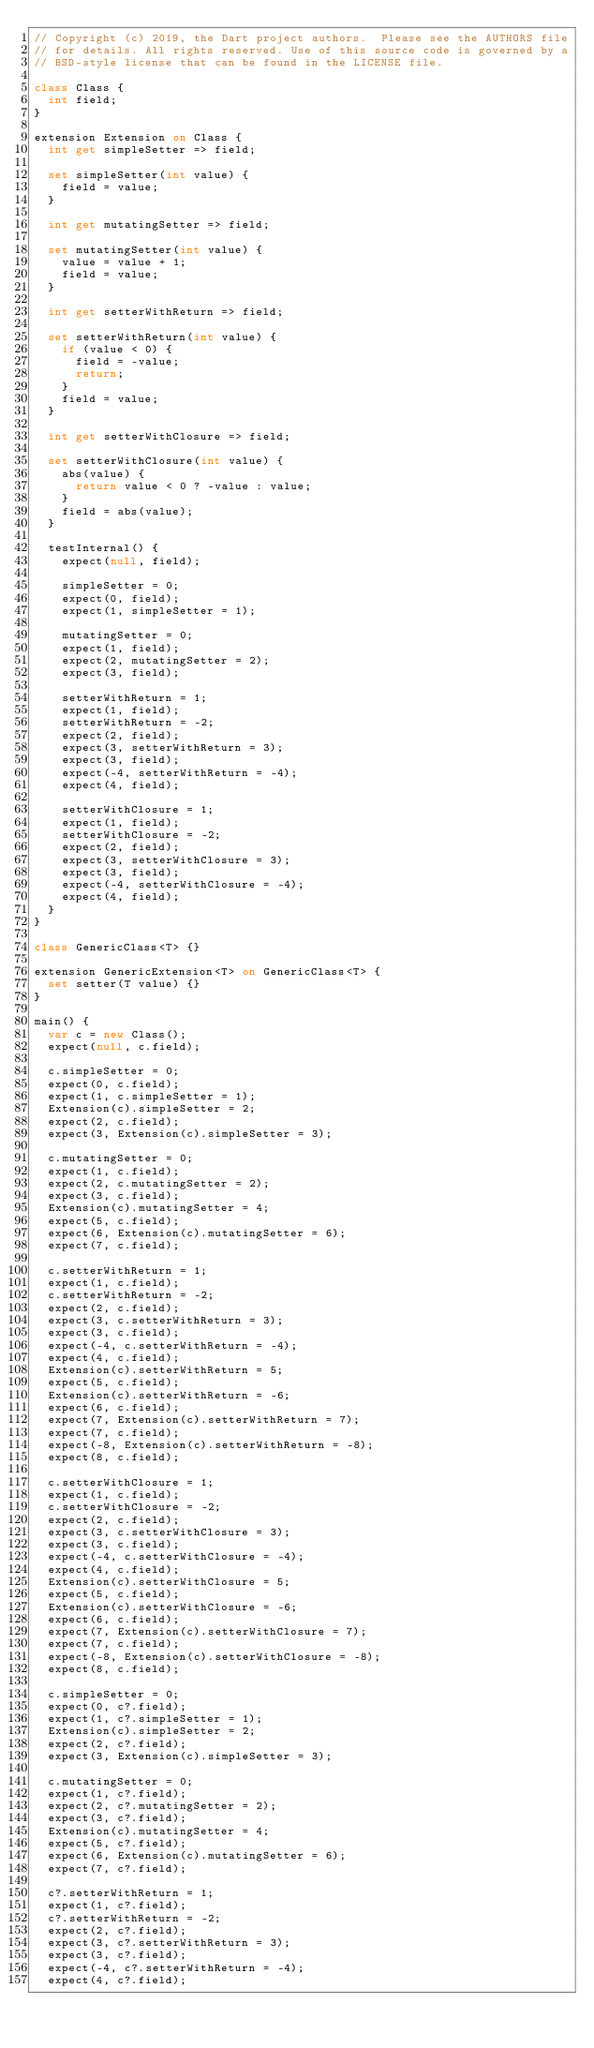<code> <loc_0><loc_0><loc_500><loc_500><_Dart_>// Copyright (c) 2019, the Dart project authors.  Please see the AUTHORS file
// for details. All rights reserved. Use of this source code is governed by a
// BSD-style license that can be found in the LICENSE file.

class Class {
  int field;
}

extension Extension on Class {
  int get simpleSetter => field;

  set simpleSetter(int value) {
    field = value;
  }

  int get mutatingSetter => field;

  set mutatingSetter(int value) {
    value = value + 1;
    field = value;
  }

  int get setterWithReturn => field;

  set setterWithReturn(int value) {
    if (value < 0) {
      field = -value;
      return;
    }
    field = value;
  }

  int get setterWithClosure => field;

  set setterWithClosure(int value) {
    abs(value) {
      return value < 0 ? -value : value;
    }
    field = abs(value);
  }
  
  testInternal() {
    expect(null, field);

    simpleSetter = 0;
    expect(0, field);
    expect(1, simpleSetter = 1);

    mutatingSetter = 0;
    expect(1, field);
    expect(2, mutatingSetter = 2);
    expect(3, field);

    setterWithReturn = 1;
    expect(1, field);
    setterWithReturn = -2;
    expect(2, field);
    expect(3, setterWithReturn = 3);
    expect(3, field);
    expect(-4, setterWithReturn = -4);
    expect(4, field);

    setterWithClosure = 1;
    expect(1, field);
    setterWithClosure = -2;
    expect(2, field);
    expect(3, setterWithClosure = 3);
    expect(3, field);
    expect(-4, setterWithClosure = -4);
    expect(4, field);
  }
}

class GenericClass<T> {}

extension GenericExtension<T> on GenericClass<T> {
  set setter(T value) {}
}

main() {
  var c = new Class();
  expect(null, c.field);

  c.simpleSetter = 0;
  expect(0, c.field);
  expect(1, c.simpleSetter = 1);
  Extension(c).simpleSetter = 2;
  expect(2, c.field);
  expect(3, Extension(c).simpleSetter = 3);

  c.mutatingSetter = 0;
  expect(1, c.field);
  expect(2, c.mutatingSetter = 2);
  expect(3, c.field);
  Extension(c).mutatingSetter = 4;
  expect(5, c.field);
  expect(6, Extension(c).mutatingSetter = 6);
  expect(7, c.field);

  c.setterWithReturn = 1;
  expect(1, c.field);
  c.setterWithReturn = -2;
  expect(2, c.field);
  expect(3, c.setterWithReturn = 3);
  expect(3, c.field);
  expect(-4, c.setterWithReturn = -4);
  expect(4, c.field);
  Extension(c).setterWithReturn = 5;
  expect(5, c.field);
  Extension(c).setterWithReturn = -6;
  expect(6, c.field);
  expect(7, Extension(c).setterWithReturn = 7);
  expect(7, c.field);
  expect(-8, Extension(c).setterWithReturn = -8);
  expect(8, c.field);

  c.setterWithClosure = 1;
  expect(1, c.field);
  c.setterWithClosure = -2;
  expect(2, c.field);
  expect(3, c.setterWithClosure = 3);
  expect(3, c.field);
  expect(-4, c.setterWithClosure = -4);
  expect(4, c.field);
  Extension(c).setterWithClosure = 5;
  expect(5, c.field);
  Extension(c).setterWithClosure = -6;
  expect(6, c.field);
  expect(7, Extension(c).setterWithClosure = 7);
  expect(7, c.field);
  expect(-8, Extension(c).setterWithClosure = -8);
  expect(8, c.field);

  c.simpleSetter = 0;
  expect(0, c?.field);
  expect(1, c?.simpleSetter = 1);
  Extension(c).simpleSetter = 2;
  expect(2, c?.field);
  expect(3, Extension(c).simpleSetter = 3);

  c.mutatingSetter = 0;
  expect(1, c?.field);
  expect(2, c?.mutatingSetter = 2);
  expect(3, c?.field);
  Extension(c).mutatingSetter = 4;
  expect(5, c?.field);
  expect(6, Extension(c).mutatingSetter = 6);
  expect(7, c?.field);

  c?.setterWithReturn = 1;
  expect(1, c?.field);
  c?.setterWithReturn = -2;
  expect(2, c?.field);
  expect(3, c?.setterWithReturn = 3);
  expect(3, c?.field);
  expect(-4, c?.setterWithReturn = -4);
  expect(4, c?.field);</code> 